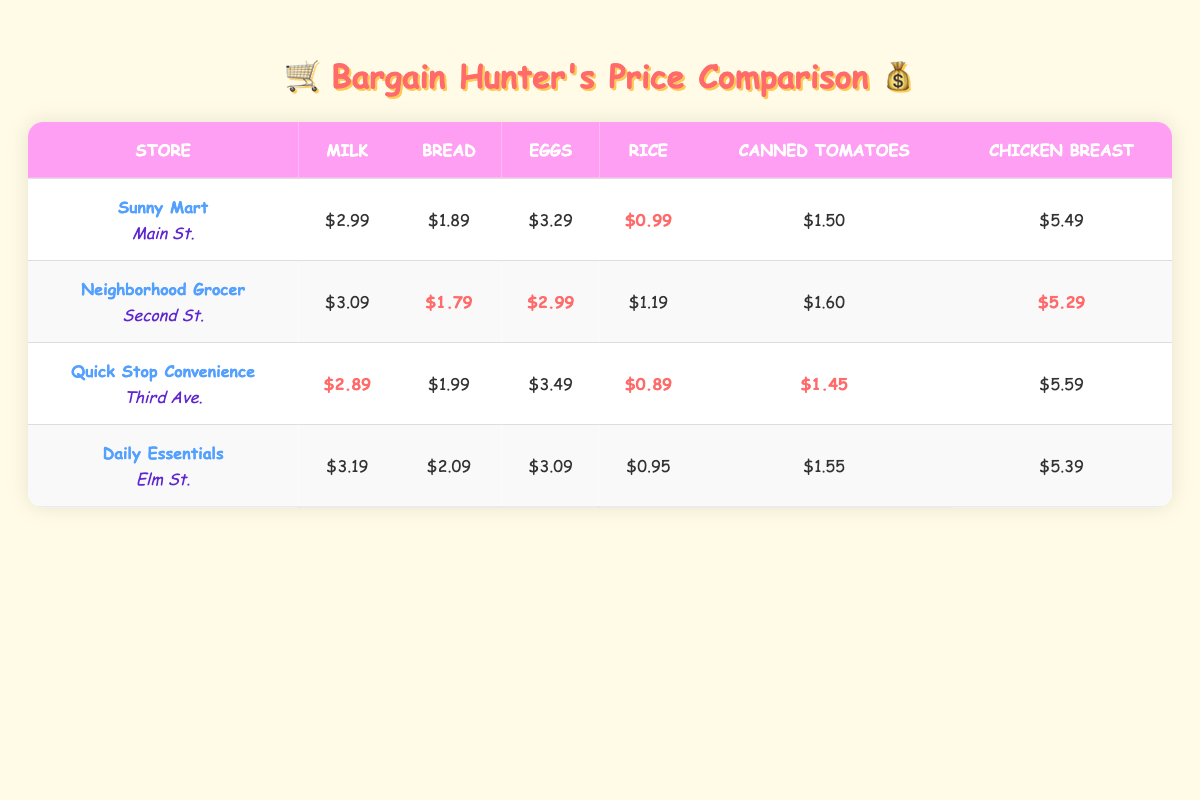What store has the lowest price for milk? The prices for milk at each store are Sunny Mart: $2.99, Neighborhood Grocer: $3.09, Quick Stop Convenience: $2.89, and Daily Essentials: $3.19. Comparing these values, Quick Stop Convenience has the lowest price at $2.89.
Answer: Quick Stop Convenience Which store offers the cheapest rice? The rice prices are as follows: Sunny Mart: $0.99, Neighborhood Grocer: $1.19, Quick Stop Convenience: $0.89, and Daily Essentials: $0.95. Quick Stop Convenience has the cheapest rice at $0.89.
Answer: Quick Stop Convenience Is the price for eggs the same at any two stores? The prices for eggs are: Sunny Mart: $3.29, Neighborhood Grocer: $2.99, Quick Stop Convenience: $3.49, and Daily Essentials: $3.09. There are no two stores with the same price for eggs based on the data provided.
Answer: No What is the total cost of purchasing milk, bread, and eggs at Sunny Mart? The costs for these items at Sunny Mart are: milk: $2.99, bread: $1.89, and eggs: $3.29. Adding these: $2.99 + $1.89 + $3.29 = $8.17. Therefore, the total cost for these items at Sunny Mart is $8.17.
Answer: $8.17 Which store has the lowest average price across all items? To find the lowest average price, we calculate the average for each store. Sunny Mart's total price: $2.99 + $1.89 + $3.29 + $0.99 + $1.50 + $5.49 = $15.15, average = $15.15/6 = $2.525. Neighborhood Grocer: $3.09 + $1.79 + $2.99 + $1.19 + $1.60 + $5.29 = $16.15, average = $16.15/6 = $2.6917. Quick Stop Convenience: $2.89 + $1.99 + $3.49 + $0.89 + $1.45 + $5.59 = $16.29, average = $16.29/6 = $2.7217. Daily Essentials: $3.19 + $2.09 + $3.09 + $0.95 + $1.55 + $5.39 = $16.46, average = $16.46/6 = $2.7433. Sunny Mart has the lowest average price of $2.525.
Answer: Sunny Mart How much more does chicken breast cost at Quick Stop Convenience than at Neighborhood Grocer? The price for chicken breast at Quick Stop Convenience is $5.59 and at Neighborhood Grocer is $5.29. To find the difference, we subtract: $5.59 - $5.29 = $0.30. Therefore, chicken breast at Quick Stop Convenience costs $0.30 more than at Neighborhood Grocer.
Answer: $0.30 